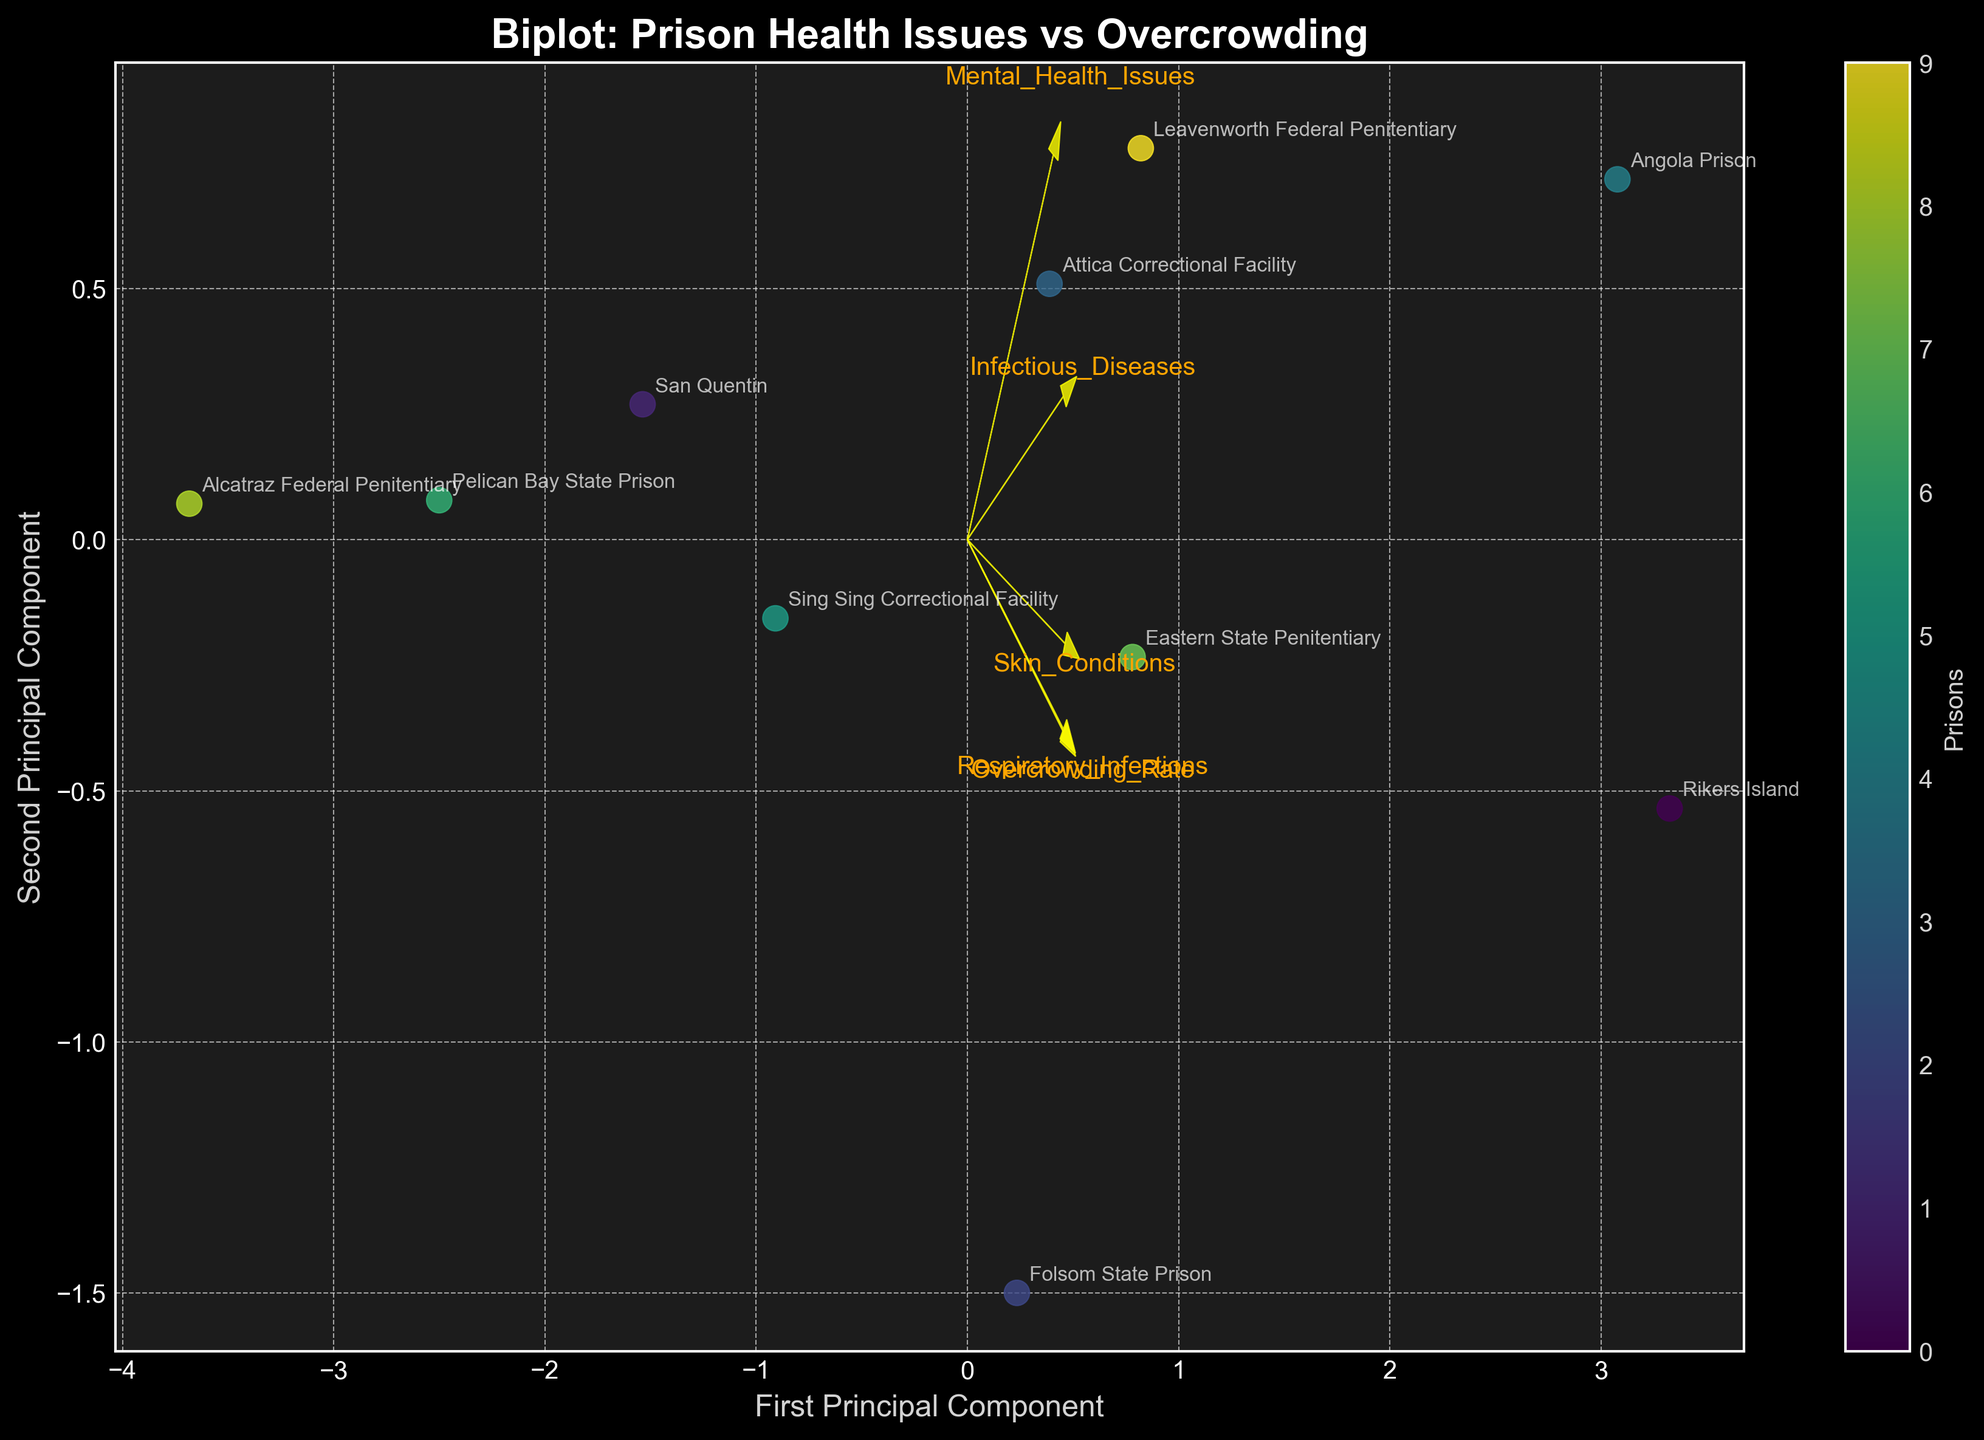What is the title of the figure? The title is typically found at the top of the figure. It summarizes the main point or context of the visualization.
Answer: Biplot: Prison Health Issues vs Overcrowding How many prisons are represented in the figure? The number of data points, each typically marked with a label (in this case, prison names), corresponds to the number of prisons. Count the labels to get the number of prisons.
Answer: 10 Which axis represents the first principal component? Axes are labeled, usually with a title next to or below them. The axis labeled "First Principal Component" is the one representing it.
Answer: The horizontal axis Which prison is associated with the highest overcrowding rate? To determine this, observe where the principal component scores of features like "Overcrowding_Rate" point the most and look at the annotations aligned in that direction.
Answer: Rikers Island Are respiratory infections more associated with the first or second principal component? To answer this, observe the direction and magnitude of the arrow representing "Respiratory_Infections". The component with the longer projection in that direction is more associated.
Answer: First principal component Which health issue lies closest to the first principal component axis? By observing the arrow plots representing different health issues, the issue with an arrow most parallel to the first principal component axis is the closest.
Answer: Respiratory Infections Which two prisons have the closest points in the biplot? Identify which two annotations (i.e., prison names) are closest to each other on the plot. Check their positions relative to both principal components.
Answer: San Quentin and Sing Sing Correctional Facility How does the overcrowding rate seem to correlate with mental health issues? Look at how closely the direction of the "Overcrowding_Rate" arrow aligns with the "Mental_Health_Issues" arrow in the biplot. The more aligned they are, the stronger the correlation.
Answer: They have a strong correlation What feature is most perpendicular to skin conditions? Find the feature whose arrow is most orthogonal (at a right angle) to the "Skin_Conditions" arrow in the plot.
Answer: Respiratory Infections Is there a visual trend between overcrowding rate and infectious diseases? Examine the alignment of the "Overcrowding_Rate" and "Infectious_Diseases" arrows. If they point in similar directions, there's a trend.
Answer: Yes, there is a trend 